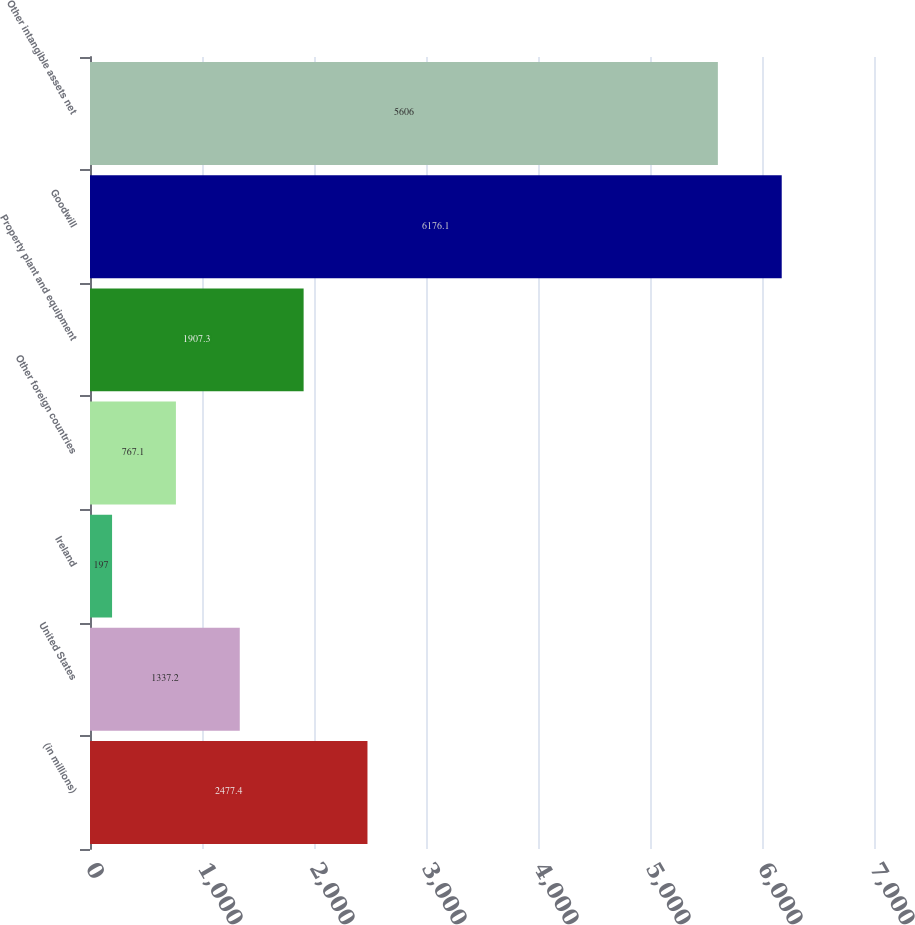Convert chart to OTSL. <chart><loc_0><loc_0><loc_500><loc_500><bar_chart><fcel>(in millions)<fcel>United States<fcel>Ireland<fcel>Other foreign countries<fcel>Property plant and equipment<fcel>Goodwill<fcel>Other intangible assets net<nl><fcel>2477.4<fcel>1337.2<fcel>197<fcel>767.1<fcel>1907.3<fcel>6176.1<fcel>5606<nl></chart> 